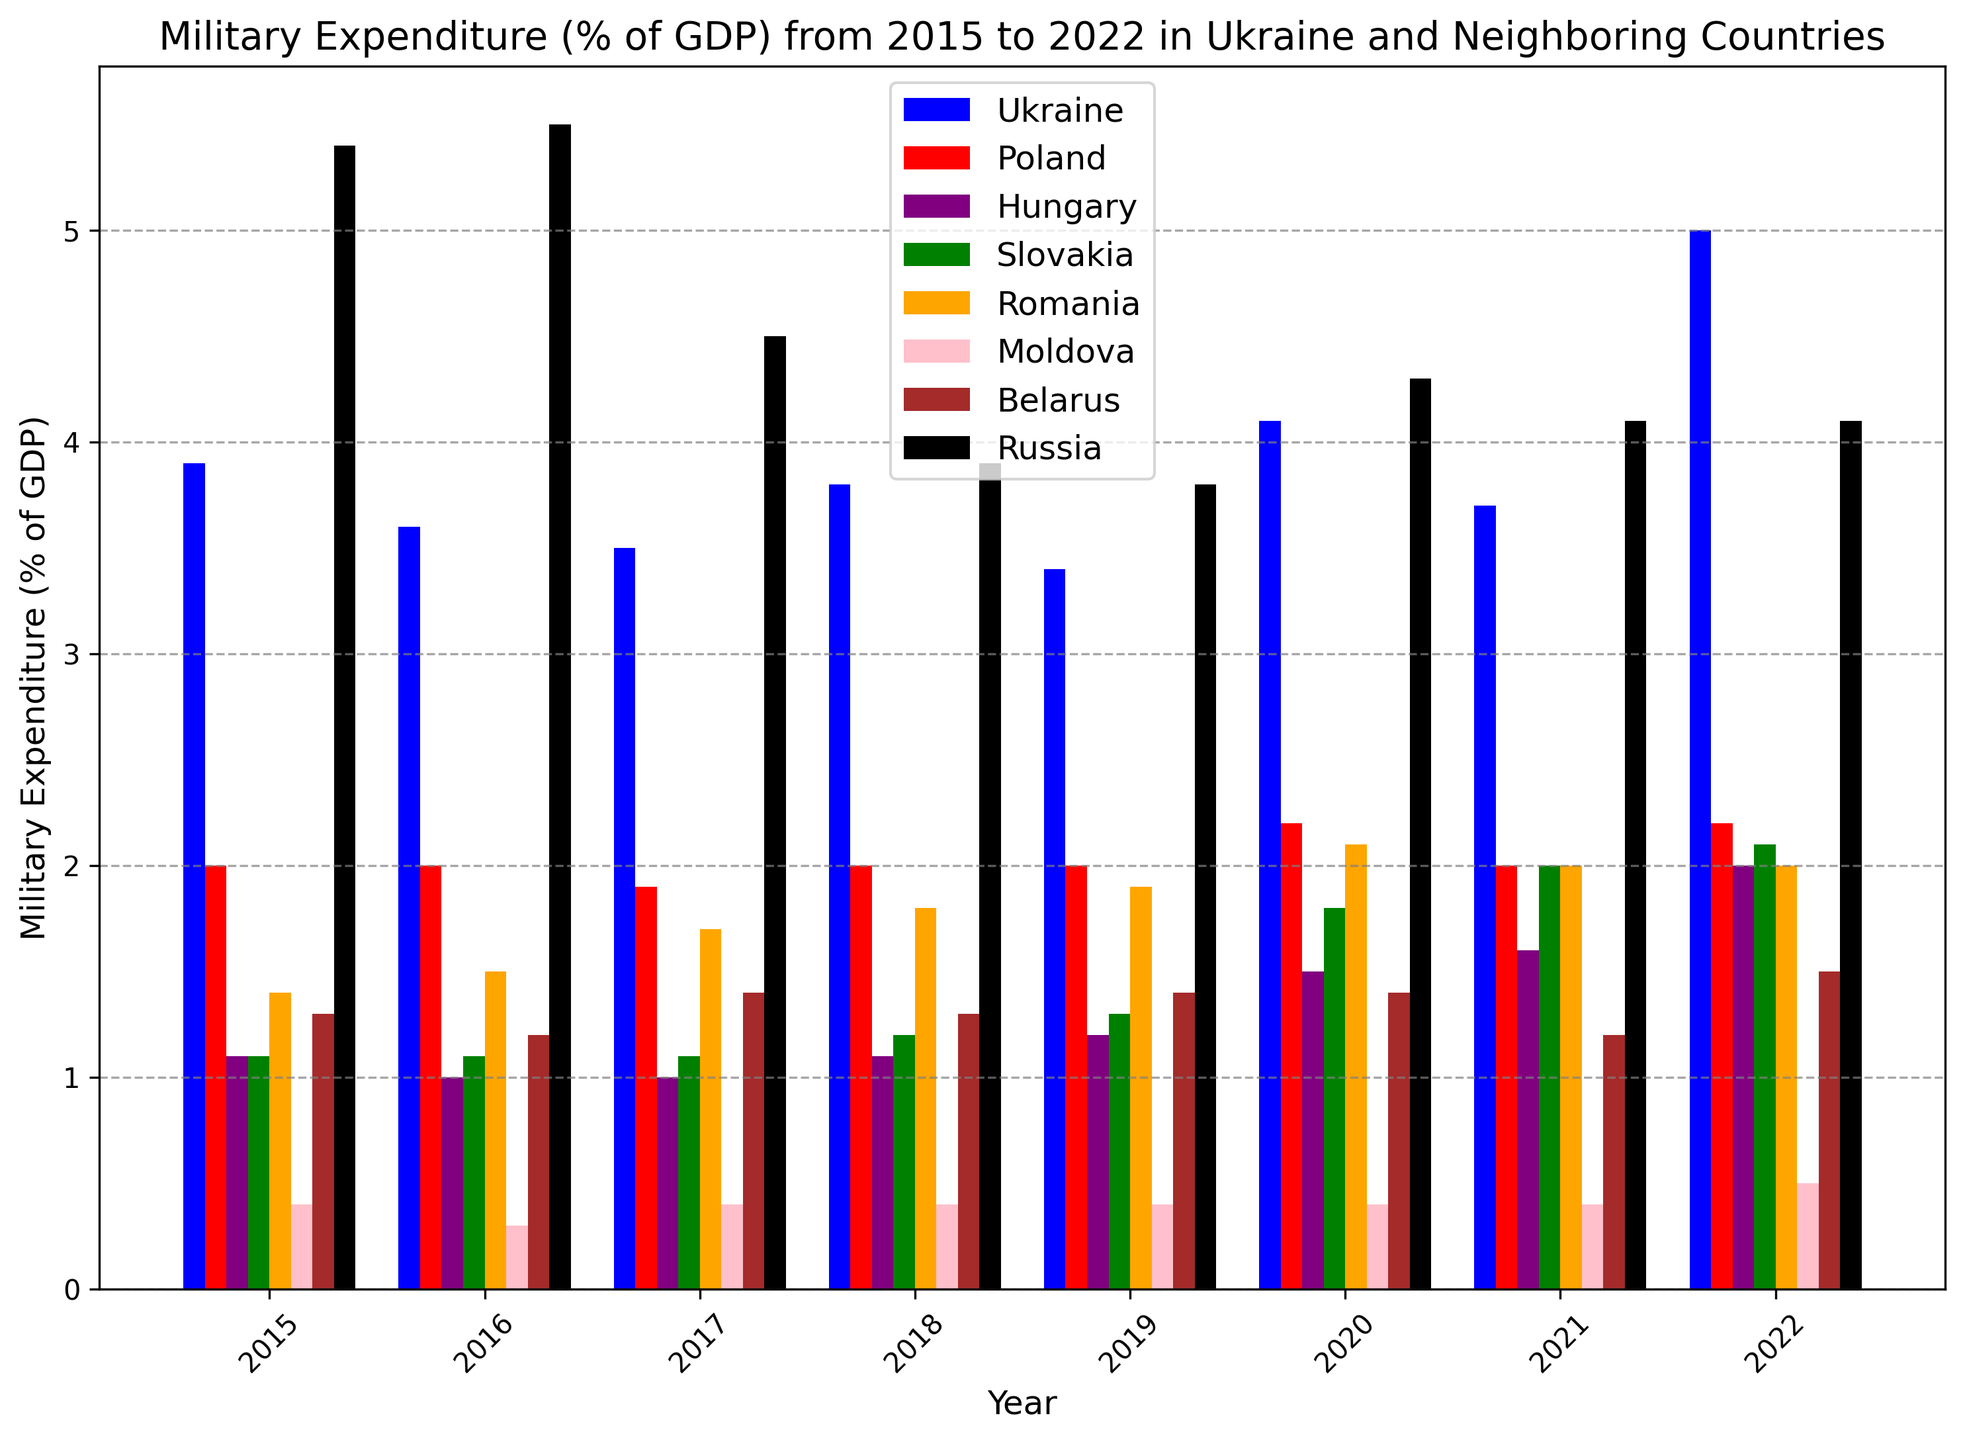Which country had the highest military expenditure as a percentage of GDP in 2015? Looking at the bar chart, we compare the heights of the bars for 2015 and see that the tallest bar represents Russia.
Answer: Russia How did Ukraine's military expenditure as a percentage of GDP change from 2015 to 2022? We locate the bars for Ukraine in 2015 and 2022, then compare their heights. In 2015, it was 3.9%, and in 2022, it was 5.0% - indicating an increase.
Answer: It increased Which two countries had the closest military expenditures as a percentage of GDP in 2017? Examining the bars for 2017, we notice that Poland and Hungary have similar bar heights, representing 1.9% and 1.0% respectively. These aren't the closest; Poland and Belarus have closer values of 1.9% and 1.4%.
Answer: Poland and Belarus In which years did Hungary's military expenditure remain constant? Reviewing the height of the bars for Hungary across the years, we find that in 2015, 2016, 2017, and 2018, the expenditure was around 1.0%-1.1%. However, it only remains fully constant between 2015 and 2017 at exactly 1.0%.
Answer: 2015 to 2017 What is the average military expenditure of Ukraine from 2015 to 2022? We add the expenditures for Ukraine from 2015 to 2022: 3.9, 3.6, 3.5, 3.8, 3.4, 4.1, 3.7, 5.0. Sum them up to get 31.0 and divide by 8 (number of years) to get the average: 31.0/8 = 3.875.
Answer: 3.875 Which country showed the most significant decrease in military expenditure as a percentage of GDP from 2015 to 2022? By comparing the heights of the bars for each country in 2015 and 2022, we see that Russia had the largest drop from 5.4% in 2015 to 4.1% in 2022.
Answer: Russia What is the difference in military expenditure percentage between Poland and Romania in 2022? Looking at the bars for Poland and Romania in 2022, Poland is at 2.2% and Romania at 2.0%. Subtracting these gives: 2.2 - 2.0 = 0.2%.
Answer: 0.2% Which country has consistently had the lowest military expenditure as a percentage of GDP? Observing all the years, Moldova consistently has the shorter bars, indicating its military expenditure has been the lowest.
Answer: Moldova Between 2016 and 2017, which country showed the greatest increase in military expenditure as a percentage of GDP? By comparing the bars for each country between 2016 and 2017, we find Romania's expenditure went up from 1.5% to 1.7%. No other country had a more significant increase.
Answer: Romania 